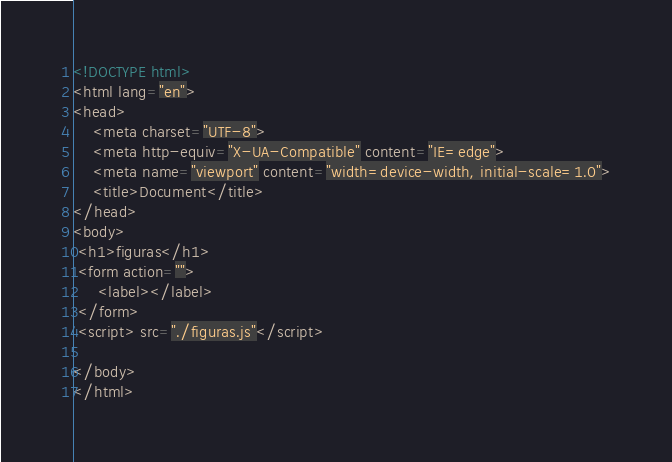Convert code to text. <code><loc_0><loc_0><loc_500><loc_500><_HTML_><!DOCTYPE html>
<html lang="en">
<head>
    <meta charset="UTF-8">
    <meta http-equiv="X-UA-Compatible" content="IE=edge">
    <meta name="viewport" content="width=device-width, initial-scale=1.0">
    <title>Document</title>
</head>
<body>
 <h1>figuras</h1> 
 <form action="">
     <label></label>
 </form>
 <script> src="./figuras.js"</script>
  
</body>
</html></code> 